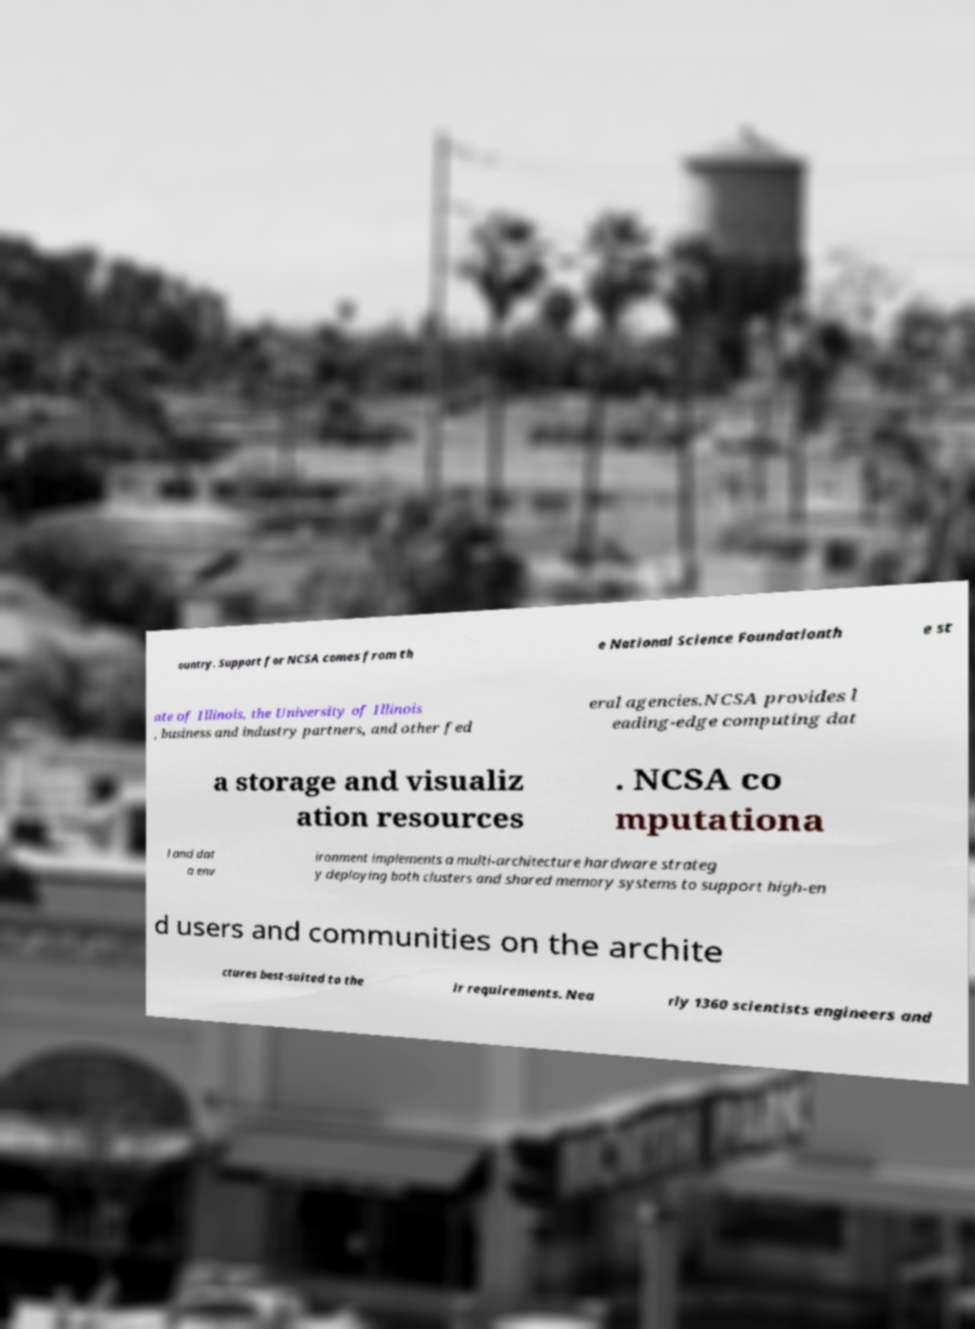Can you accurately transcribe the text from the provided image for me? ountry. Support for NCSA comes from th e National Science Foundationth e st ate of Illinois, the University of Illinois , business and industry partners, and other fed eral agencies.NCSA provides l eading-edge computing dat a storage and visualiz ation resources . NCSA co mputationa l and dat a env ironment implements a multi-architecture hardware strateg y deploying both clusters and shared memory systems to support high-en d users and communities on the archite ctures best-suited to the ir requirements. Nea rly 1360 scientists engineers and 